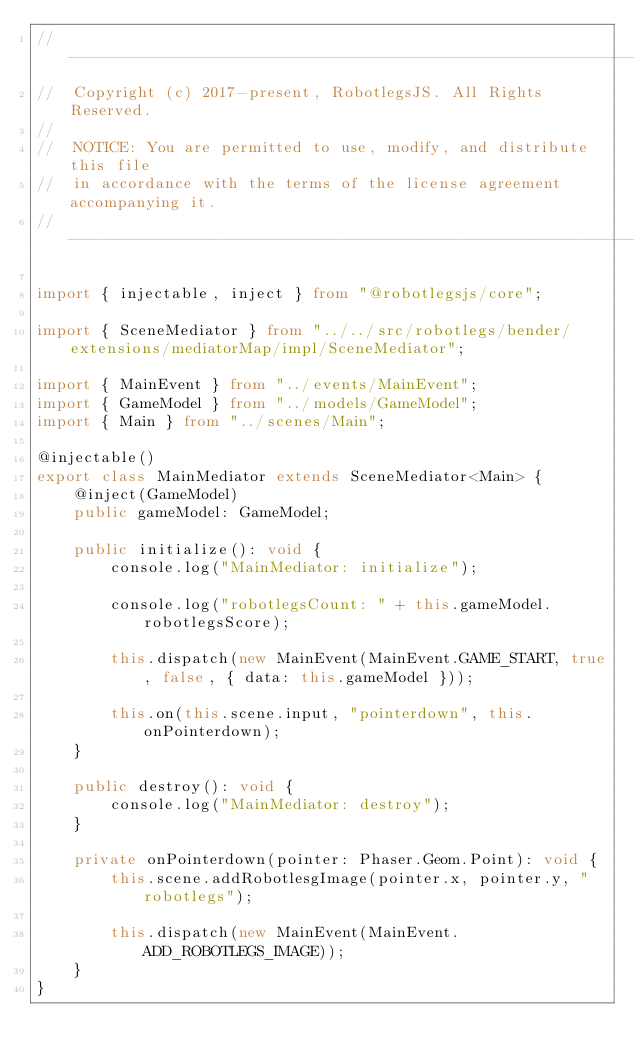Convert code to text. <code><loc_0><loc_0><loc_500><loc_500><_TypeScript_>// ------------------------------------------------------------------------------
//  Copyright (c) 2017-present, RobotlegsJS. All Rights Reserved.
//
//  NOTICE: You are permitted to use, modify, and distribute this file
//  in accordance with the terms of the license agreement accompanying it.
// ------------------------------------------------------------------------------

import { injectable, inject } from "@robotlegsjs/core";

import { SceneMediator } from "../../src/robotlegs/bender/extensions/mediatorMap/impl/SceneMediator";

import { MainEvent } from "../events/MainEvent";
import { GameModel } from "../models/GameModel";
import { Main } from "../scenes/Main";

@injectable()
export class MainMediator extends SceneMediator<Main> {
    @inject(GameModel)
    public gameModel: GameModel;

    public initialize(): void {
        console.log("MainMediator: initialize");

        console.log("robotlegsCount: " + this.gameModel.robotlegsScore);

        this.dispatch(new MainEvent(MainEvent.GAME_START, true, false, { data: this.gameModel }));

        this.on(this.scene.input, "pointerdown", this.onPointerdown);
    }

    public destroy(): void {
        console.log("MainMediator: destroy");
    }

    private onPointerdown(pointer: Phaser.Geom.Point): void {
        this.scene.addRobotlesgImage(pointer.x, pointer.y, "robotlegs");

        this.dispatch(new MainEvent(MainEvent.ADD_ROBOTLEGS_IMAGE));
    }
}
</code> 